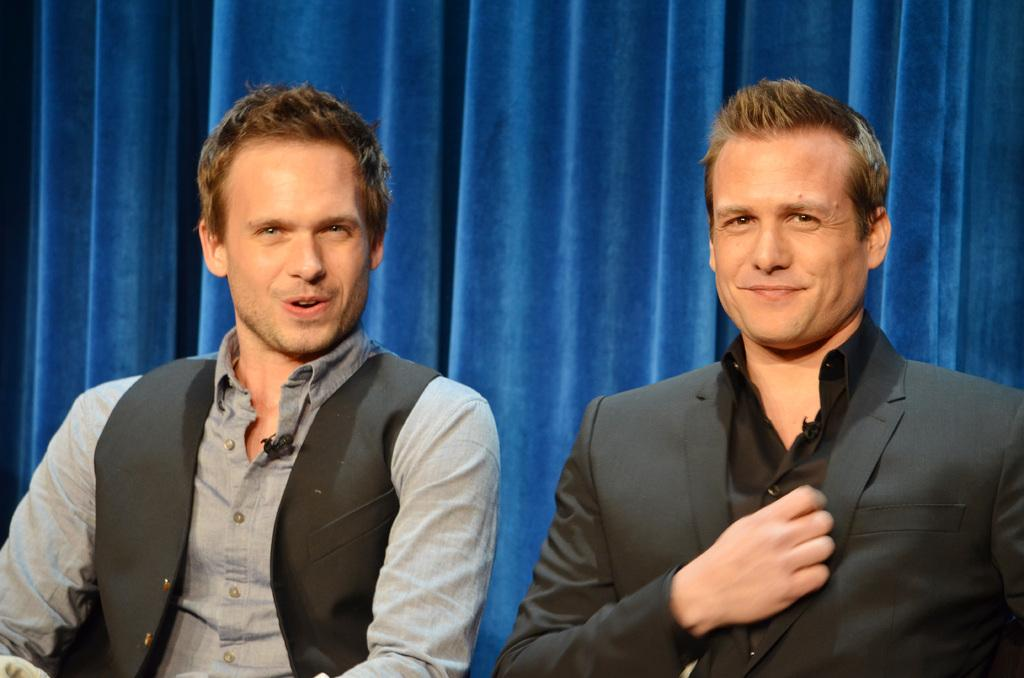How many people are present in the image? There are two persons sitting in the image. What can be seen in the background of the image? There is a curtain visible in the background of the image. What type of shirt is the crowd wearing in the image? There is no crowd present in the image, and therefore no shirt can be associated with a crowd. 